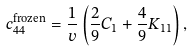Convert formula to latex. <formula><loc_0><loc_0><loc_500><loc_500>c _ { 4 4 } ^ { \text {frozen} } = \frac { 1 } { v } \left ( { \frac { 2 } { 9 } } C _ { 1 } + { \frac { 4 } { 9 } } K _ { 1 1 } \right ) ,</formula> 